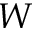<formula> <loc_0><loc_0><loc_500><loc_500>W</formula> 